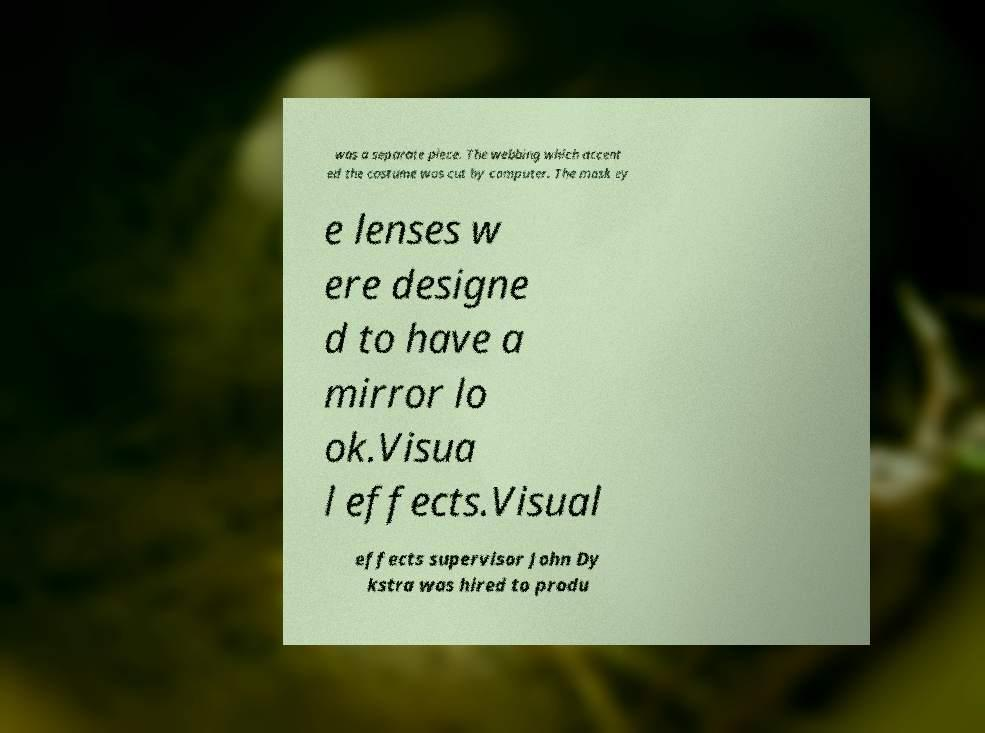Could you extract and type out the text from this image? was a separate piece. The webbing which accent ed the costume was cut by computer. The mask ey e lenses w ere designe d to have a mirror lo ok.Visua l effects.Visual effects supervisor John Dy kstra was hired to produ 